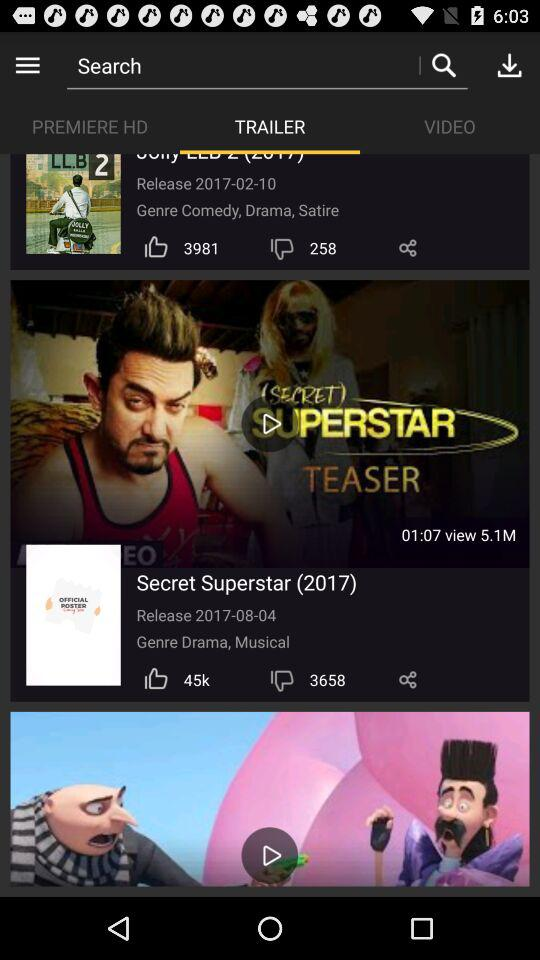How many dislikes are there for Secret Superstar? There are 3658 dislikes. 